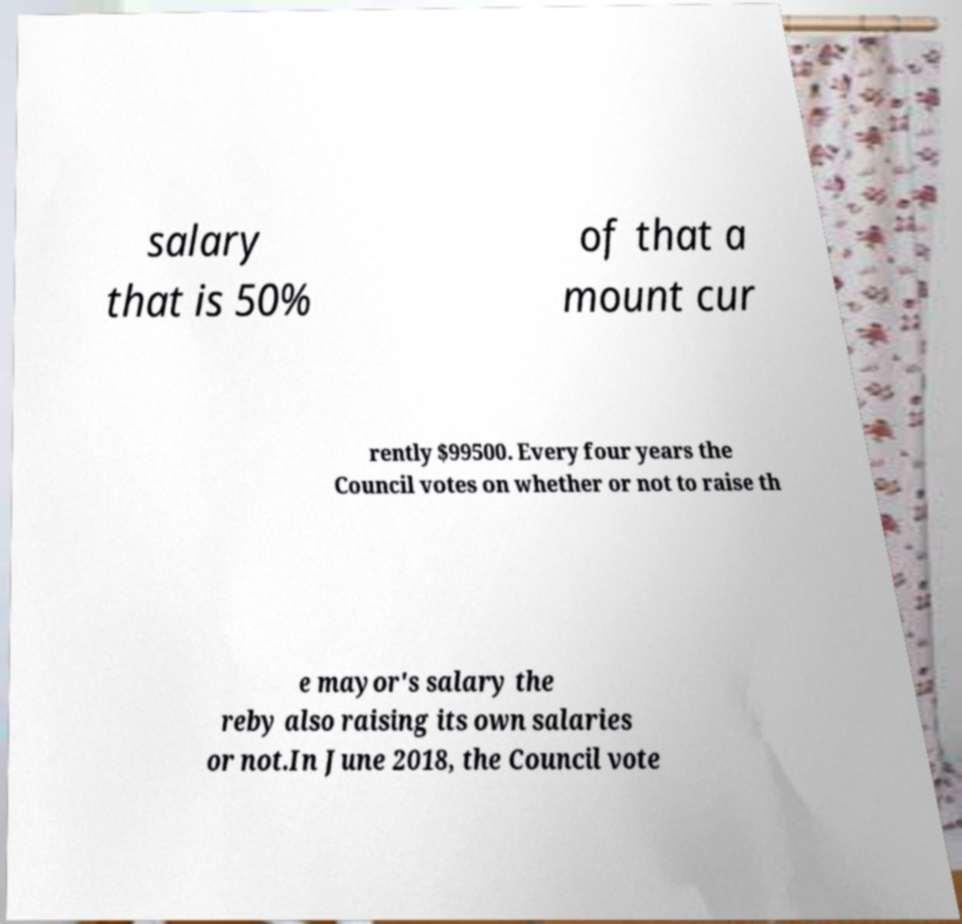What messages or text are displayed in this image? I need them in a readable, typed format. salary that is 50% of that a mount cur rently $99500. Every four years the Council votes on whether or not to raise th e mayor's salary the reby also raising its own salaries or not.In June 2018, the Council vote 